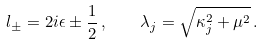<formula> <loc_0><loc_0><loc_500><loc_500>l _ { \pm } = 2 i \epsilon \pm \frac { 1 } { 2 } \, , \quad \lambda _ { j } = \sqrt { \kappa _ { j } ^ { 2 } + \mu ^ { 2 } } \, .</formula> 